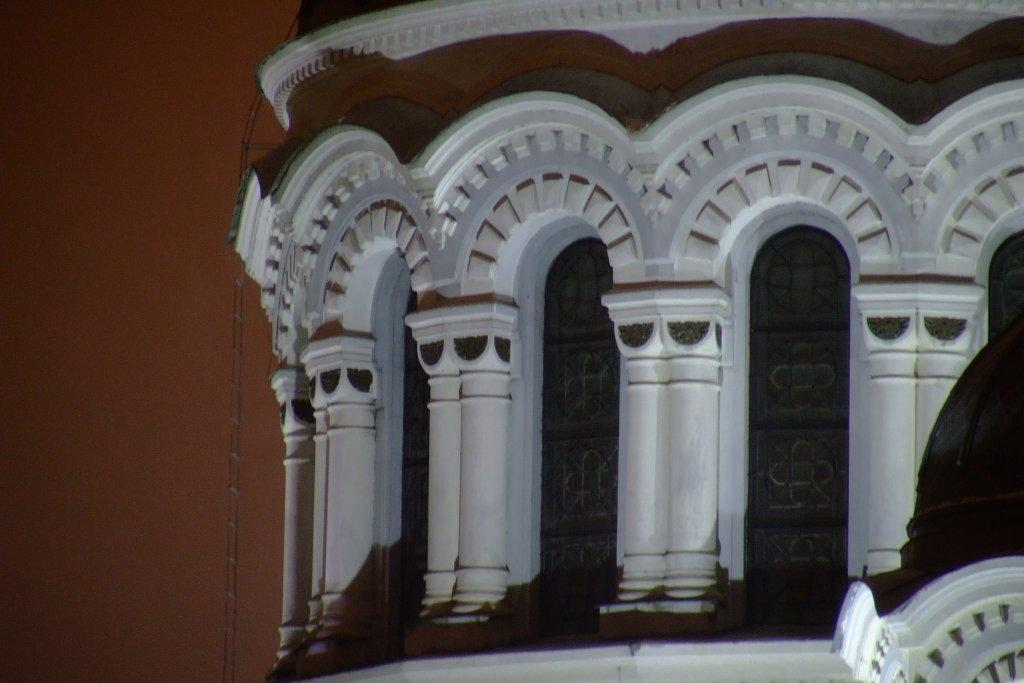What color is the wall on the left side of the image? The wall on the left side of the image is red. What structure is located in the middle of the image? There is a building in the middle of the image. What type of wood can be seen in the image? There is no wood present in the image; it features a red wall and a building. What activity is taking place in the image? The image does not depict any specific activity; it shows a red wall and a building. 